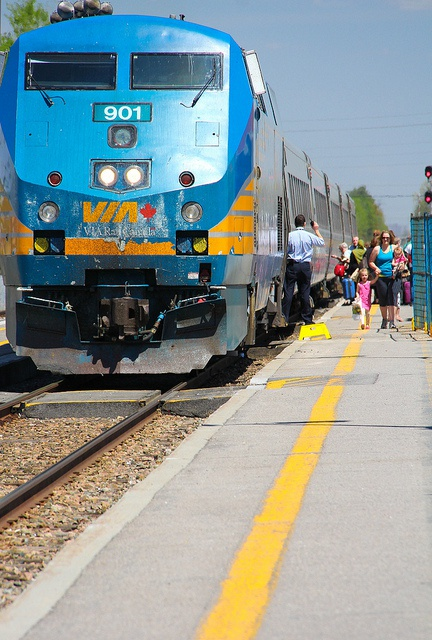Describe the objects in this image and their specific colors. I can see train in gray, black, lightblue, and darkgray tones, people in gray, black, lavender, and darkgray tones, people in gray, black, brown, and darkblue tones, people in gray, white, violet, and brown tones, and people in gray, darkgray, white, and maroon tones in this image. 